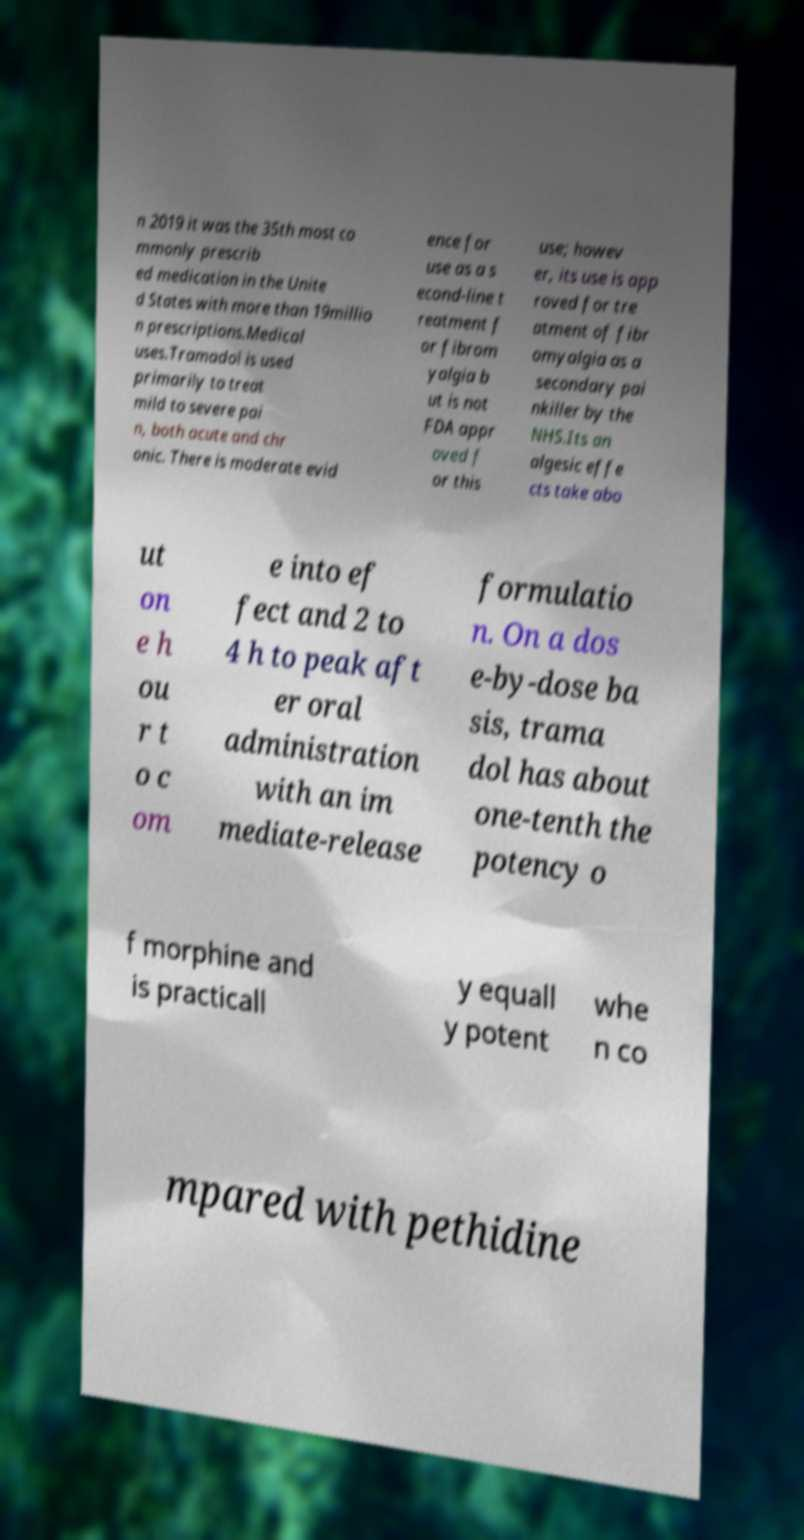For documentation purposes, I need the text within this image transcribed. Could you provide that? n 2019 it was the 35th most co mmonly prescrib ed medication in the Unite d States with more than 19millio n prescriptions.Medical uses.Tramadol is used primarily to treat mild to severe pai n, both acute and chr onic. There is moderate evid ence for use as a s econd-line t reatment f or fibrom yalgia b ut is not FDA appr oved f or this use; howev er, its use is app roved for tre atment of fibr omyalgia as a secondary pai nkiller by the NHS.Its an algesic effe cts take abo ut on e h ou r t o c om e into ef fect and 2 to 4 h to peak aft er oral administration with an im mediate-release formulatio n. On a dos e-by-dose ba sis, trama dol has about one-tenth the potency o f morphine and is practicall y equall y potent whe n co mpared with pethidine 